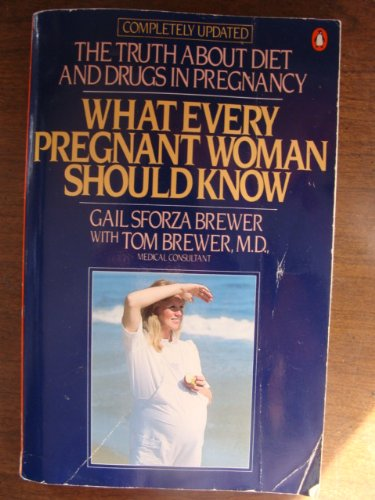Who wrote this book? The book 'What Every Pregnant Woman Should Know' was authored by Gail Sforza Brewer, in collaboration with Dr. Tom Brewer as medical consultant. 